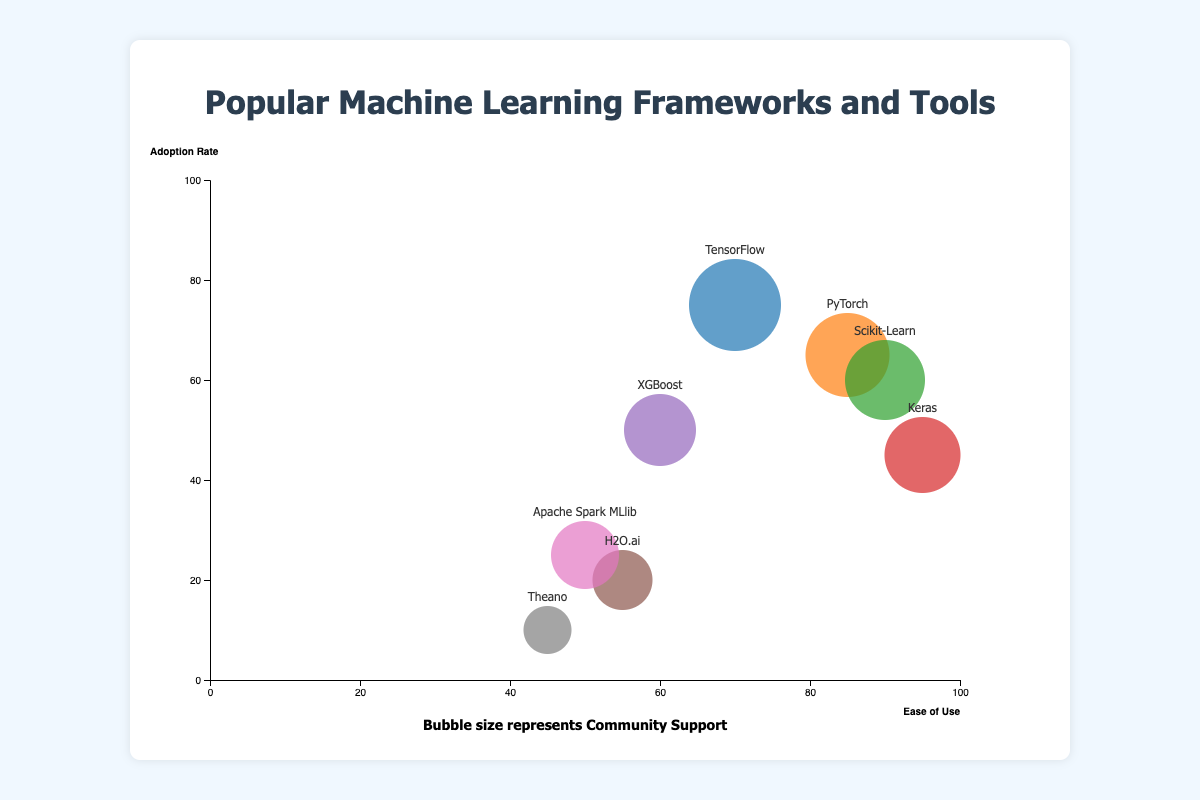What is the title of the chart? The title is always placed at the top of the chart and gives an idea of what the chart represents. In this case, it is "Popular Machine Learning Frameworks and Tools".
Answer: Popular Machine Learning Frameworks and Tools What framework has the highest adoption rate? By looking at the y-axis, which represents adoption rate, and identifying the bubble positioned closest to the top, we see that "TensorFlow" has the highest adoption rate of 75%.
Answer: TensorFlow Which framework has the largest bubble size? Bubble size represents community support. The largest bubble is visually identified as the one that is biggest in size, which corresponds to "TensorFlow" with 90% community support.
Answer: TensorFlow How does the adoption rate of Scikit-Learn compare to that of Keras? The y-axis represents adoption rate. Scikit-Learn is positioned at an adoption rate of 60%, while Keras is at 45%. Therefore, Scikit-Learn has a higher adoption rate than Keras.
Answer: Scikit-Learn has a higher adoption rate than Keras What is the ease of use for PyTorch and how does it compare to TensorFlow? PyTorch has an ease of use of 85%, while TensorFlow has 70% on the x-axis representing ease of use. Thus, PyTorch is considered easier to use than TensorFlow.
Answer: PyTorch is easier to use than TensorFlow Which framework has the lowest community support and what is its adoption rate? The smallest bubble represents the lowest community support, which is "Theano" at 35%. Its adoption rate, indicated by its position on the y-axis, is 10%.
Answer: Theano, 10% What is the average adoption rate of TensorFlow and PyTorch? The adoption rates are 75% for TensorFlow and 65% for PyTorch. The average is calculated as (75 + 65) / 2 = 70%.
Answer: 70% How many frameworks have an ease of use above 80%? By checking the x-axis for values above 80% and counting the corresponding bubbles, we see that there are three frameworks: PyTorch, Scikit-Learn, and Keras.
Answer: 3 Which framework has the highest community support but an ease of use below 60%? Combining the information from bubble sizes and their positions on the x-axis, we see that "XGBoost" has a community support of 65% and an ease of use of 60% or lower.
Answer: XGBoost What can you infer about the popularity and usability of Keras? Keras has a relatively low adoption rate of 45% (y-axis) but is rated very high on ease of use at 95% (x-axis). Its bubble size (70%) indicates good community support. This suggests that while not the most adopted, it is highly appreciated for its ease of use and has decent community backing.
Answer: Highly usable with decent community support but lower adoption 